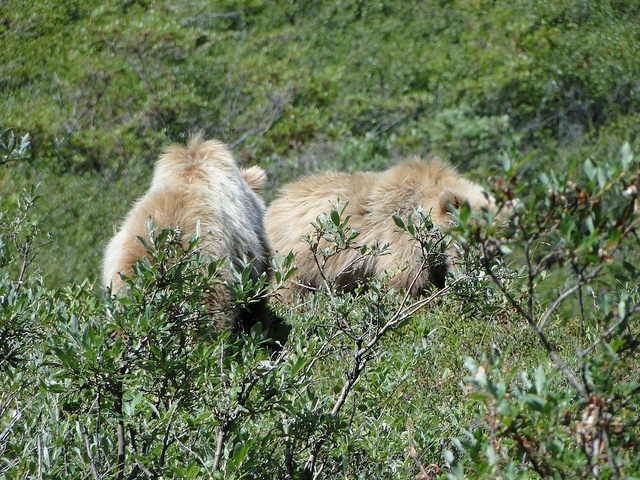Describe the objects in this image and their specific colors. I can see bear in gray, darkgray, and tan tones and bear in gray, darkgray, lightgray, and black tones in this image. 